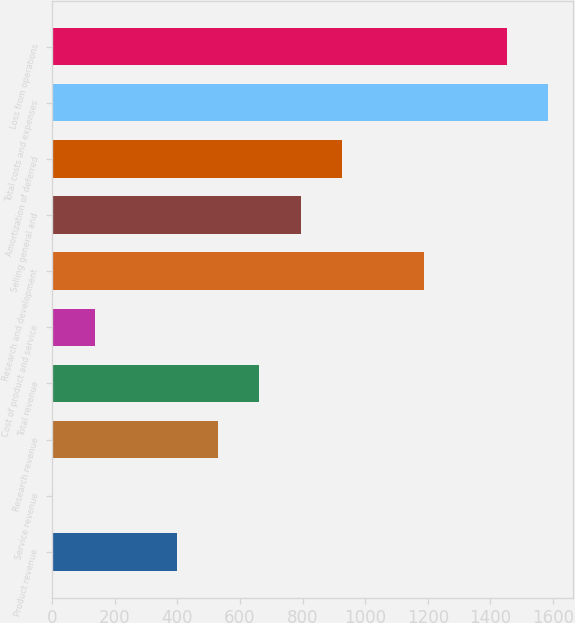Convert chart. <chart><loc_0><loc_0><loc_500><loc_500><bar_chart><fcel>Product revenue<fcel>Service revenue<fcel>Research revenue<fcel>Total revenue<fcel>Cost of product and service<fcel>Research and development<fcel>Selling general and<fcel>Amortization of deferred<fcel>Total costs and expenses<fcel>Loss from operations<nl><fcel>398.8<fcel>4<fcel>530.4<fcel>662<fcel>135.6<fcel>1188.4<fcel>793.6<fcel>925.2<fcel>1583.2<fcel>1451.6<nl></chart> 